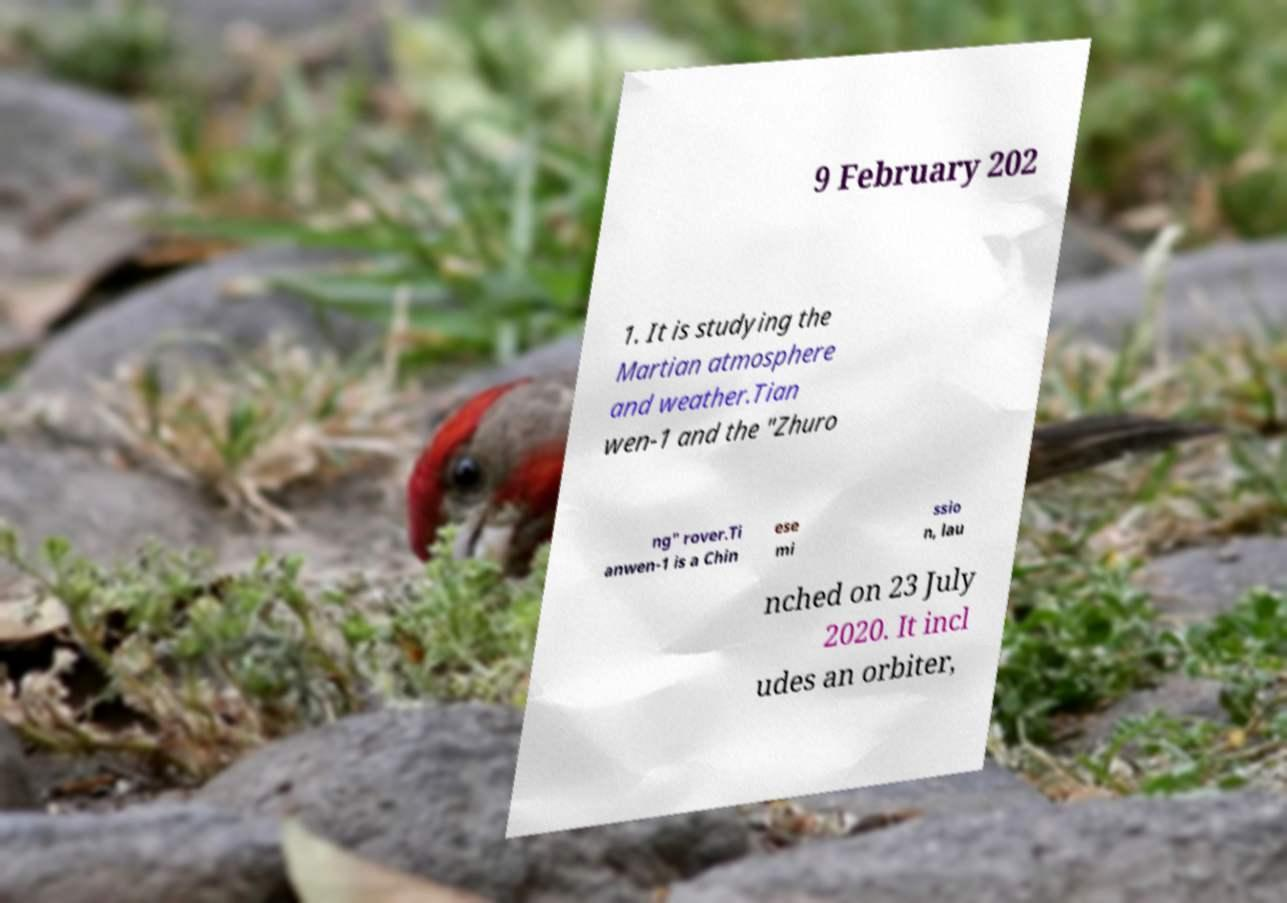Please identify and transcribe the text found in this image. 9 February 202 1. It is studying the Martian atmosphere and weather.Tian wen-1 and the "Zhuro ng" rover.Ti anwen-1 is a Chin ese mi ssio n, lau nched on 23 July 2020. It incl udes an orbiter, 